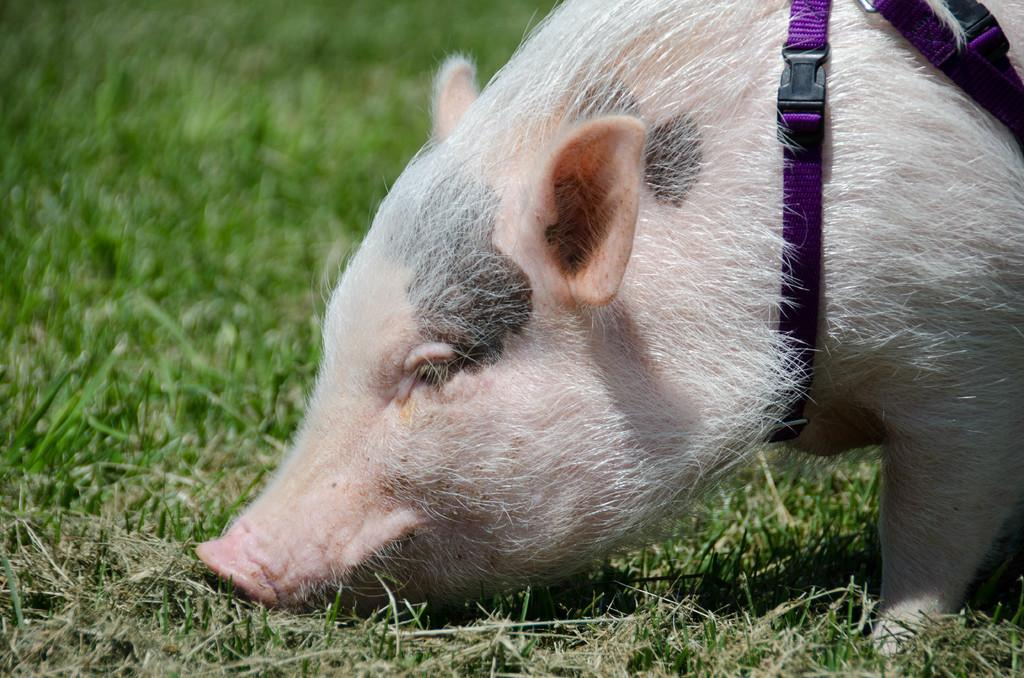What animal is present in the image? There is a pig in the image. What type of terrain is the pig on? The pig is on grassy land. Does the pig have any distinguishing features? Yes, the pig has a purple color belt. What type of soup is being served to the boys on the island in the image? There is no soup, boys, or island present in the image; it only features a pig with a purple color belt on grassy land. 